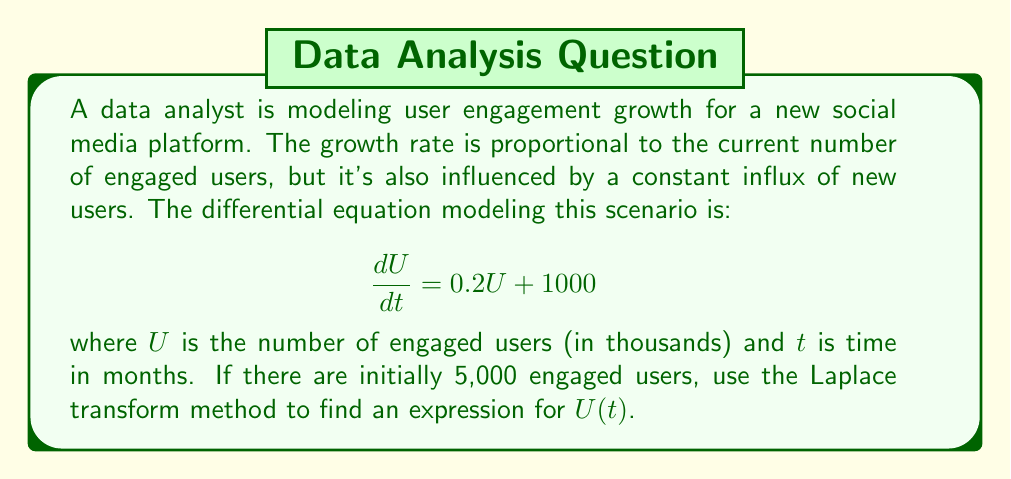Give your solution to this math problem. To solve this differential equation using the Laplace transform method, we'll follow these steps:

1) Take the Laplace transform of both sides of the equation:
   $$\mathcal{L}\left\{\frac{dU}{dt}\right\} = \mathcal{L}\{0.2U + 1000\}$$

2) Using the linearity property and the Laplace transform of a constant:
   $$s\mathcal{L}\{U\} - U(0) = 0.2\mathcal{L}\{U\} + \frac{1000}{s}$$

3) Let $\mathcal{L}\{U\} = F(s)$. Substitute the initial condition $U(0) = 5$:
   $$sF(s) - 5 = 0.2F(s) + \frac{1000}{s}$$

4) Rearrange the equation:
   $$(s - 0.2)F(s) = 5 + \frac{1000}{s}$$

5) Solve for $F(s)$:
   $$F(s) = \frac{5}{s - 0.2} + \frac{1000}{s(s - 0.2)}$$

6) Decompose into partial fractions:
   $$F(s) = \frac{5}{s - 0.2} + \frac{A}{s} + \frac{B}{s - 0.2}$$
   
   where $A = -5000$ and $B = 5000$

7) Rewrite as:
   $$F(s) = \frac{5}{s - 0.2} - \frac{5000}{s} + \frac{5000}{s - 0.2}$$

8) Take the inverse Laplace transform:
   $$U(t) = 5e^{0.2t} - 5000 + 5000e^{0.2t}$$

9) Simplify:
   $$U(t) = 5005e^{0.2t} - 5000$$

This gives us the expression for the number of engaged users (in thousands) at time $t$ (in months).
Answer: $U(t) = 5005e^{0.2t} - 5000$, where $U$ is in thousands of users and $t$ is in months. 